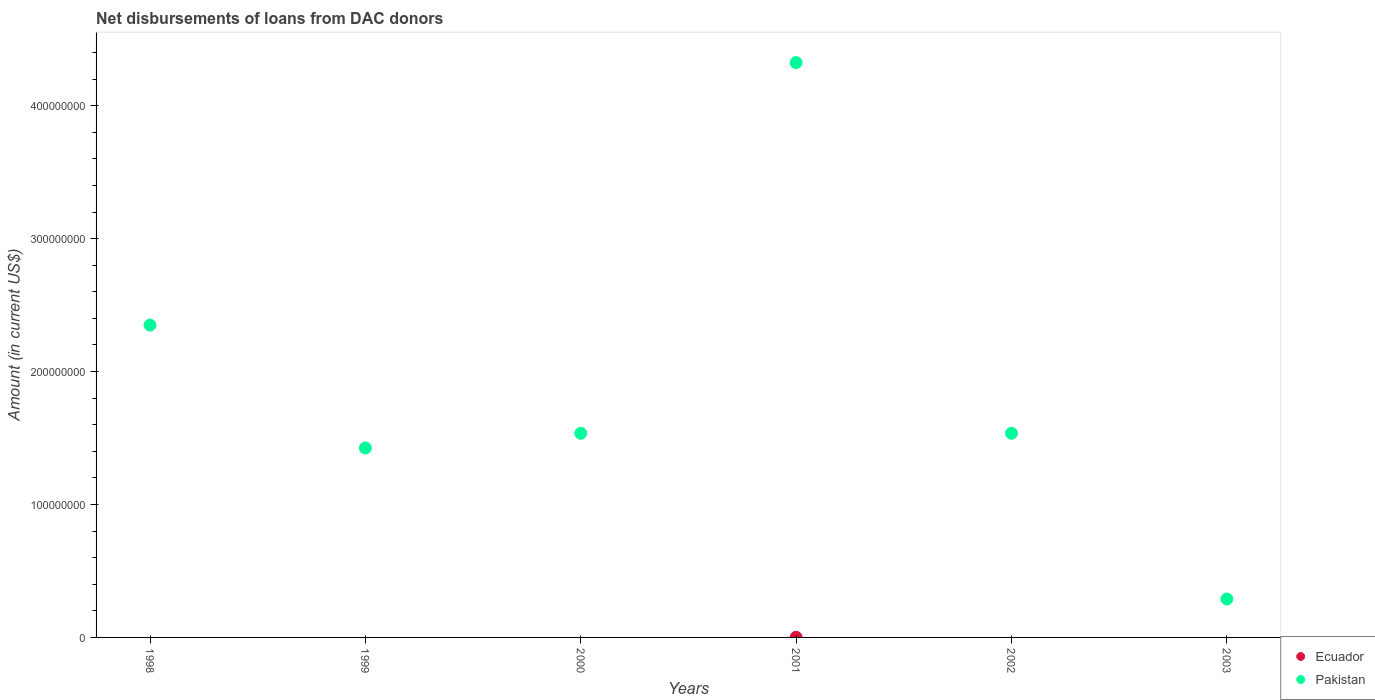How many different coloured dotlines are there?
Your response must be concise. 2. Is the number of dotlines equal to the number of legend labels?
Make the answer very short. No. What is the amount of loans disbursed in Pakistan in 1999?
Offer a very short reply. 1.43e+08. Across all years, what is the maximum amount of loans disbursed in Pakistan?
Offer a terse response. 4.32e+08. What is the total amount of loans disbursed in Pakistan in the graph?
Ensure brevity in your answer.  1.15e+09. What is the difference between the amount of loans disbursed in Pakistan in 1999 and that in 2002?
Keep it short and to the point. -1.11e+07. What is the difference between the amount of loans disbursed in Pakistan in 2003 and the amount of loans disbursed in Ecuador in 1999?
Offer a terse response. 2.89e+07. What is the average amount of loans disbursed in Pakistan per year?
Your answer should be very brief. 1.91e+08. In how many years, is the amount of loans disbursed in Ecuador greater than 80000000 US$?
Make the answer very short. 0. What is the ratio of the amount of loans disbursed in Pakistan in 1998 to that in 2003?
Provide a short and direct response. 8.13. Is the amount of loans disbursed in Pakistan in 2001 less than that in 2002?
Your answer should be very brief. No. What is the difference between the highest and the second highest amount of loans disbursed in Pakistan?
Offer a terse response. 1.98e+08. What is the difference between the highest and the lowest amount of loans disbursed in Pakistan?
Your answer should be compact. 4.04e+08. In how many years, is the amount of loans disbursed in Pakistan greater than the average amount of loans disbursed in Pakistan taken over all years?
Ensure brevity in your answer.  2. Does the amount of loans disbursed in Ecuador monotonically increase over the years?
Offer a very short reply. No. Is the amount of loans disbursed in Ecuador strictly greater than the amount of loans disbursed in Pakistan over the years?
Offer a very short reply. No. Are the values on the major ticks of Y-axis written in scientific E-notation?
Offer a very short reply. No. What is the title of the graph?
Ensure brevity in your answer.  Net disbursements of loans from DAC donors. Does "Bolivia" appear as one of the legend labels in the graph?
Offer a very short reply. No. What is the Amount (in current US$) in Ecuador in 1998?
Provide a succinct answer. 0. What is the Amount (in current US$) of Pakistan in 1998?
Offer a terse response. 2.35e+08. What is the Amount (in current US$) of Pakistan in 1999?
Your response must be concise. 1.43e+08. What is the Amount (in current US$) in Ecuador in 2000?
Provide a succinct answer. 0. What is the Amount (in current US$) of Pakistan in 2000?
Your answer should be very brief. 1.54e+08. What is the Amount (in current US$) in Ecuador in 2001?
Your answer should be compact. 1.27e+05. What is the Amount (in current US$) of Pakistan in 2001?
Your response must be concise. 4.32e+08. What is the Amount (in current US$) of Pakistan in 2002?
Offer a very short reply. 1.54e+08. What is the Amount (in current US$) in Ecuador in 2003?
Ensure brevity in your answer.  0. What is the Amount (in current US$) in Pakistan in 2003?
Keep it short and to the point. 2.89e+07. Across all years, what is the maximum Amount (in current US$) of Ecuador?
Your answer should be compact. 1.27e+05. Across all years, what is the maximum Amount (in current US$) in Pakistan?
Provide a short and direct response. 4.32e+08. Across all years, what is the minimum Amount (in current US$) in Ecuador?
Offer a terse response. 0. Across all years, what is the minimum Amount (in current US$) of Pakistan?
Give a very brief answer. 2.89e+07. What is the total Amount (in current US$) of Ecuador in the graph?
Your response must be concise. 1.27e+05. What is the total Amount (in current US$) in Pakistan in the graph?
Give a very brief answer. 1.15e+09. What is the difference between the Amount (in current US$) in Pakistan in 1998 and that in 1999?
Provide a short and direct response. 9.24e+07. What is the difference between the Amount (in current US$) of Pakistan in 1998 and that in 2000?
Provide a short and direct response. 8.14e+07. What is the difference between the Amount (in current US$) of Pakistan in 1998 and that in 2001?
Your response must be concise. -1.98e+08. What is the difference between the Amount (in current US$) of Pakistan in 1998 and that in 2002?
Offer a very short reply. 8.14e+07. What is the difference between the Amount (in current US$) in Pakistan in 1998 and that in 2003?
Keep it short and to the point. 2.06e+08. What is the difference between the Amount (in current US$) in Pakistan in 1999 and that in 2000?
Offer a terse response. -1.10e+07. What is the difference between the Amount (in current US$) of Pakistan in 1999 and that in 2001?
Give a very brief answer. -2.90e+08. What is the difference between the Amount (in current US$) in Pakistan in 1999 and that in 2002?
Keep it short and to the point. -1.11e+07. What is the difference between the Amount (in current US$) of Pakistan in 1999 and that in 2003?
Offer a very short reply. 1.14e+08. What is the difference between the Amount (in current US$) in Pakistan in 2000 and that in 2001?
Keep it short and to the point. -2.79e+08. What is the difference between the Amount (in current US$) in Pakistan in 2000 and that in 2002?
Ensure brevity in your answer.  -1.80e+04. What is the difference between the Amount (in current US$) in Pakistan in 2000 and that in 2003?
Your response must be concise. 1.25e+08. What is the difference between the Amount (in current US$) in Pakistan in 2001 and that in 2002?
Your answer should be very brief. 2.79e+08. What is the difference between the Amount (in current US$) in Pakistan in 2001 and that in 2003?
Make the answer very short. 4.04e+08. What is the difference between the Amount (in current US$) of Pakistan in 2002 and that in 2003?
Your answer should be very brief. 1.25e+08. What is the difference between the Amount (in current US$) of Ecuador in 2001 and the Amount (in current US$) of Pakistan in 2002?
Ensure brevity in your answer.  -1.53e+08. What is the difference between the Amount (in current US$) in Ecuador in 2001 and the Amount (in current US$) in Pakistan in 2003?
Give a very brief answer. -2.88e+07. What is the average Amount (in current US$) of Ecuador per year?
Your answer should be very brief. 2.12e+04. What is the average Amount (in current US$) of Pakistan per year?
Offer a terse response. 1.91e+08. In the year 2001, what is the difference between the Amount (in current US$) in Ecuador and Amount (in current US$) in Pakistan?
Provide a short and direct response. -4.32e+08. What is the ratio of the Amount (in current US$) of Pakistan in 1998 to that in 1999?
Ensure brevity in your answer.  1.65. What is the ratio of the Amount (in current US$) of Pakistan in 1998 to that in 2000?
Ensure brevity in your answer.  1.53. What is the ratio of the Amount (in current US$) of Pakistan in 1998 to that in 2001?
Keep it short and to the point. 0.54. What is the ratio of the Amount (in current US$) of Pakistan in 1998 to that in 2002?
Ensure brevity in your answer.  1.53. What is the ratio of the Amount (in current US$) of Pakistan in 1998 to that in 2003?
Give a very brief answer. 8.13. What is the ratio of the Amount (in current US$) of Pakistan in 1999 to that in 2000?
Your answer should be very brief. 0.93. What is the ratio of the Amount (in current US$) of Pakistan in 1999 to that in 2001?
Your answer should be very brief. 0.33. What is the ratio of the Amount (in current US$) in Pakistan in 1999 to that in 2002?
Provide a succinct answer. 0.93. What is the ratio of the Amount (in current US$) in Pakistan in 1999 to that in 2003?
Provide a short and direct response. 4.93. What is the ratio of the Amount (in current US$) in Pakistan in 2000 to that in 2001?
Make the answer very short. 0.36. What is the ratio of the Amount (in current US$) of Pakistan in 2000 to that in 2003?
Your answer should be compact. 5.32. What is the ratio of the Amount (in current US$) in Pakistan in 2001 to that in 2002?
Your answer should be compact. 2.82. What is the ratio of the Amount (in current US$) of Pakistan in 2001 to that in 2003?
Keep it short and to the point. 14.97. What is the ratio of the Amount (in current US$) in Pakistan in 2002 to that in 2003?
Give a very brief answer. 5.32. What is the difference between the highest and the second highest Amount (in current US$) of Pakistan?
Give a very brief answer. 1.98e+08. What is the difference between the highest and the lowest Amount (in current US$) of Ecuador?
Provide a short and direct response. 1.27e+05. What is the difference between the highest and the lowest Amount (in current US$) in Pakistan?
Ensure brevity in your answer.  4.04e+08. 